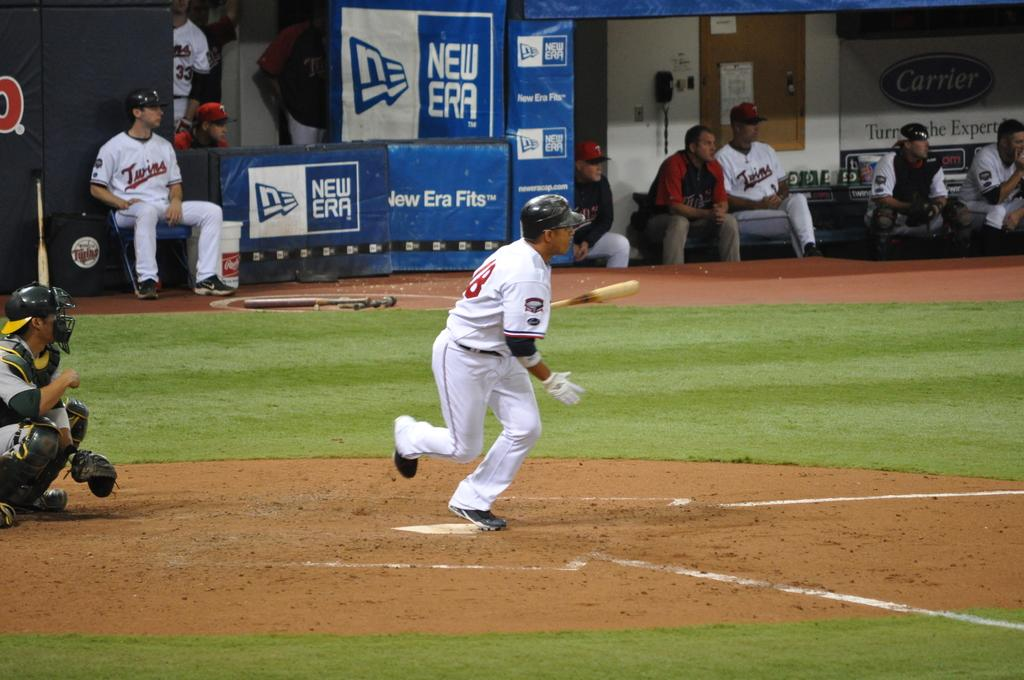What sport are the people playing in the image? The people are playing baseball in the image. Where is the baseball game taking place? The baseball game is taking place on the ground. Can you describe the people in the background of the image? In the background, there are people sitting on chairs. How many tickets are required to enter the baseball game in the image? There is no mention of tickets or an entrance fee in the image; it simply shows people playing baseball on the ground. 